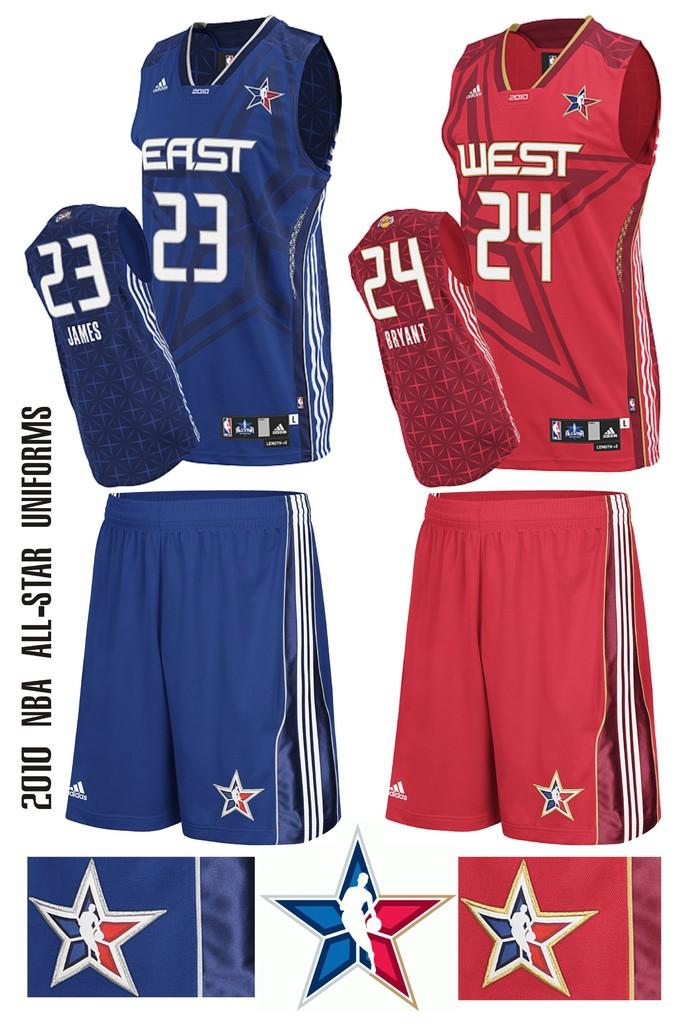<image>
Summarize the visual content of the image. A display of two different sports uniforms with one saying EAST and one saying WEST on the front. 